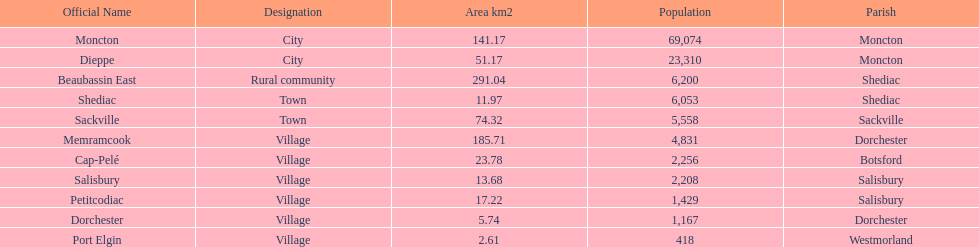City in the same parish of moncton Dieppe. 